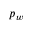<formula> <loc_0><loc_0><loc_500><loc_500>p _ { w }</formula> 